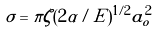Convert formula to latex. <formula><loc_0><loc_0><loc_500><loc_500>\sigma = \pi \zeta ( 2 \alpha / E ) ^ { 1 / 2 } a _ { o } ^ { 2 }</formula> 